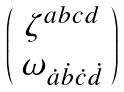Convert formula to latex. <formula><loc_0><loc_0><loc_500><loc_500>\left ( \begin{array} { c } \zeta ^ { a b c d } \\ \omega _ { \dot { a } \dot { b } \dot { c } \dot { d } } \end{array} \right )</formula> 